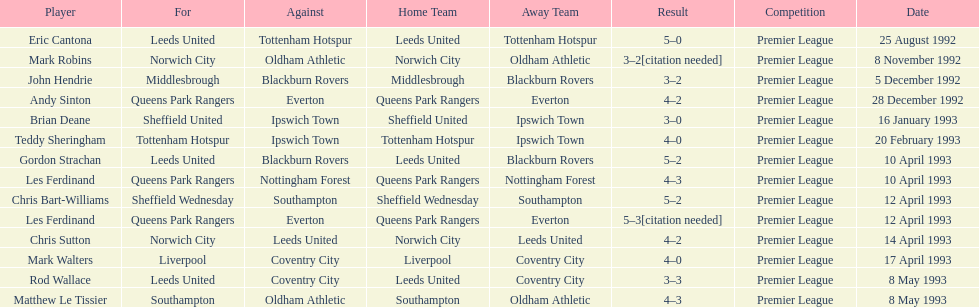Who does john hendrie play for? Middlesbrough. 